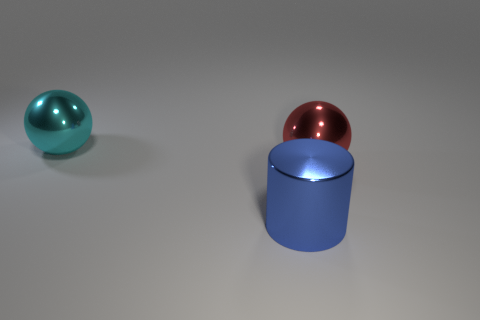There is a big object behind the large shiny sphere that is in front of the cyan shiny sphere; what is it made of?
Provide a short and direct response. Metal. What number of metallic things are behind the metallic cylinder and in front of the cyan object?
Provide a succinct answer. 1. There is a large metal thing that is in front of the large red metallic object; is it the same shape as the large metal thing that is right of the large metallic cylinder?
Make the answer very short. No. Are there any big red metal spheres to the right of the red metallic thing?
Offer a very short reply. No. The other large thing that is the same shape as the red thing is what color?
Provide a succinct answer. Cyan. Are there any other things that are the same shape as the big red metallic thing?
Provide a short and direct response. Yes. There is a large sphere that is to the right of the cyan metal object; what is its material?
Your answer should be very brief. Metal. There is a red metallic thing that is the same shape as the cyan metal thing; what size is it?
Offer a very short reply. Large. How many objects are the same material as the large cyan ball?
Your answer should be very brief. 2. What number of large balls have the same color as the big shiny cylinder?
Provide a short and direct response. 0. 